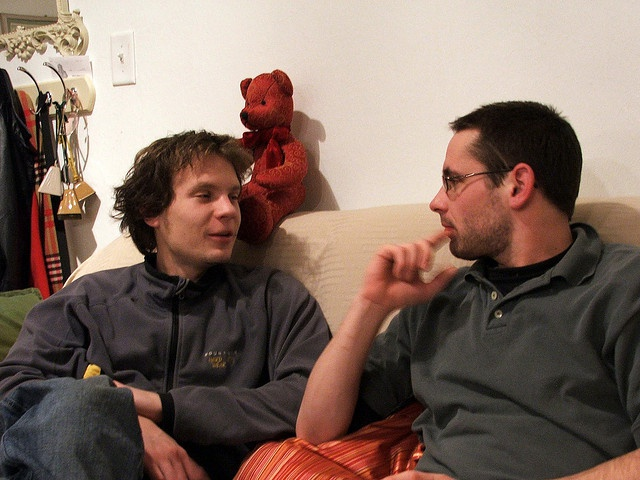Describe the objects in this image and their specific colors. I can see people in gray, black, maroon, and brown tones, people in gray, black, maroon, and brown tones, couch in gray, tan, and black tones, teddy bear in gray, maroon, black, brown, and lightgray tones, and tie in gray, black, brown, and maroon tones in this image. 